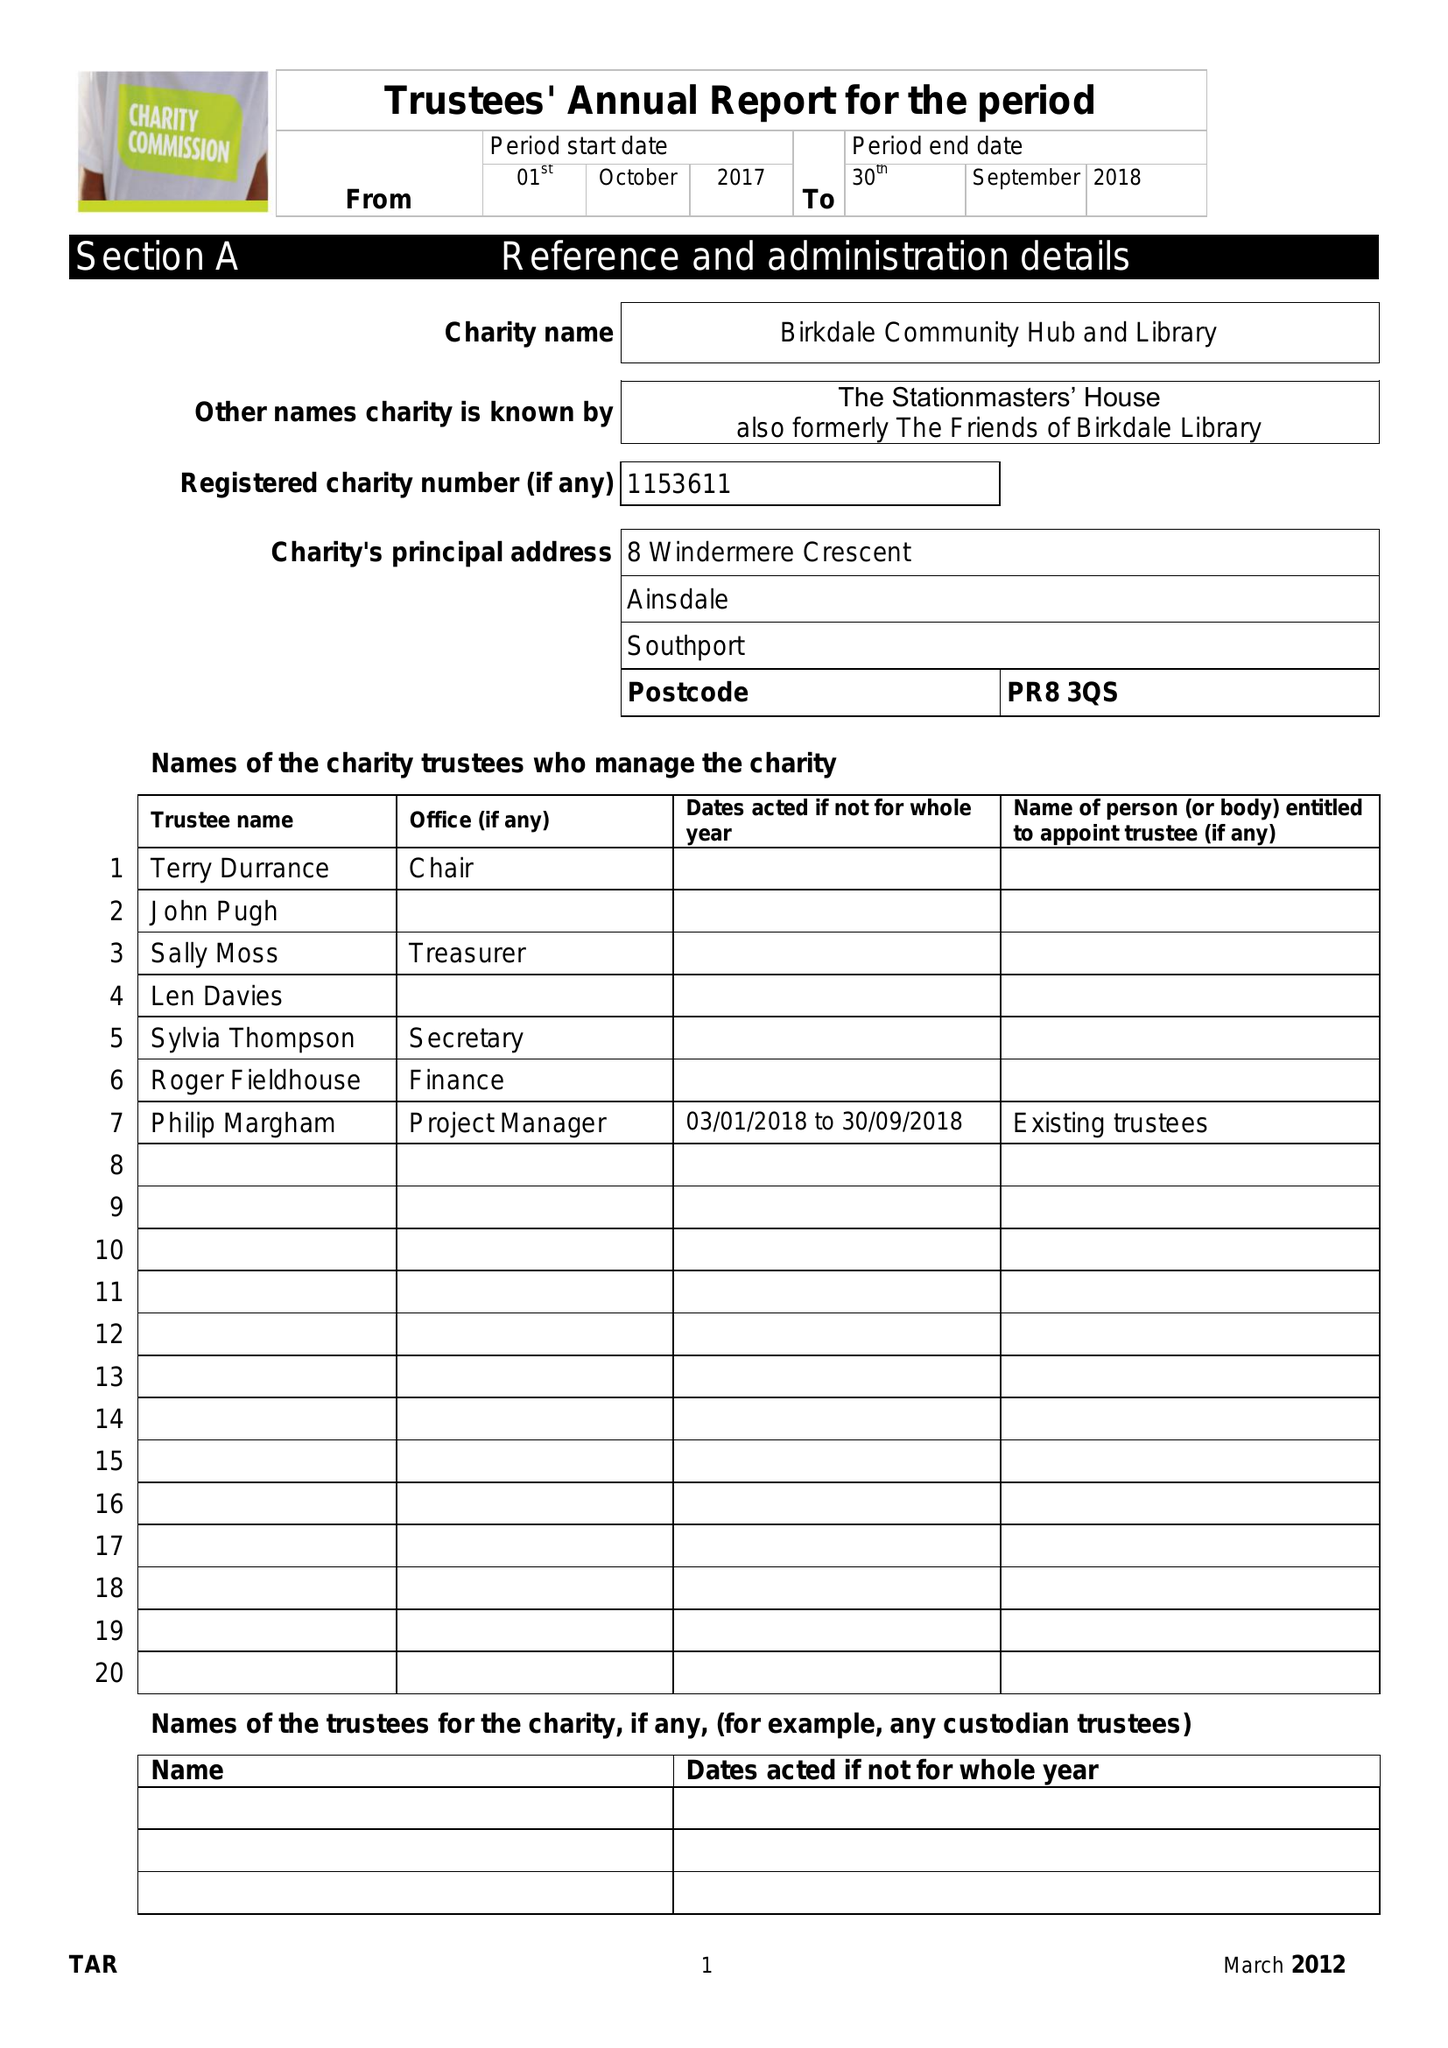What is the value for the spending_annually_in_british_pounds?
Answer the question using a single word or phrase. 3378.00 